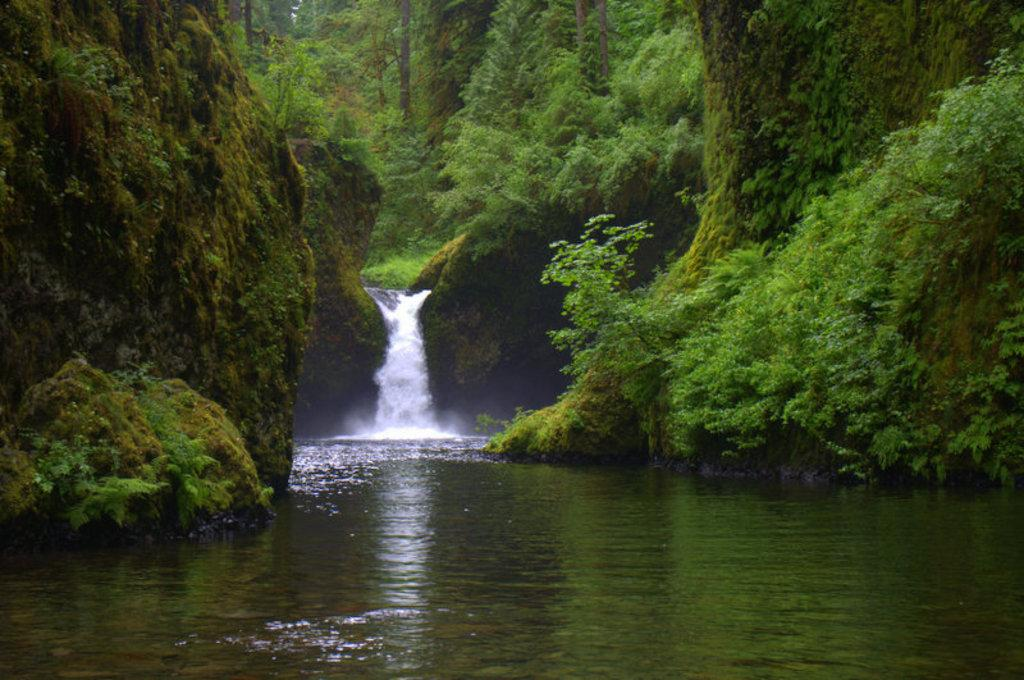What type of natural elements can be seen in the image? There are trees and hills in the image. What specific feature is located in the middle of the image? There is a waterfall in the middle of the image. What type of snack is being served on a cushion in the image? There is no snack or cushion present in the image; it features trees, hills, and a waterfall. 